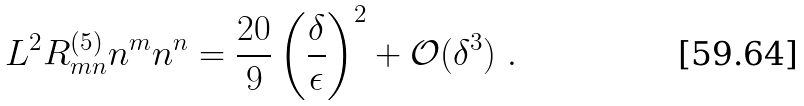Convert formula to latex. <formula><loc_0><loc_0><loc_500><loc_500>L ^ { 2 } R ^ { ( 5 ) } _ { m n } n ^ { m } n ^ { n } = \frac { 2 0 } { 9 } \left ( \frac { \delta } { \epsilon } \right ) ^ { 2 } + \mathcal { O } ( \delta ^ { 3 } ) \ .</formula> 